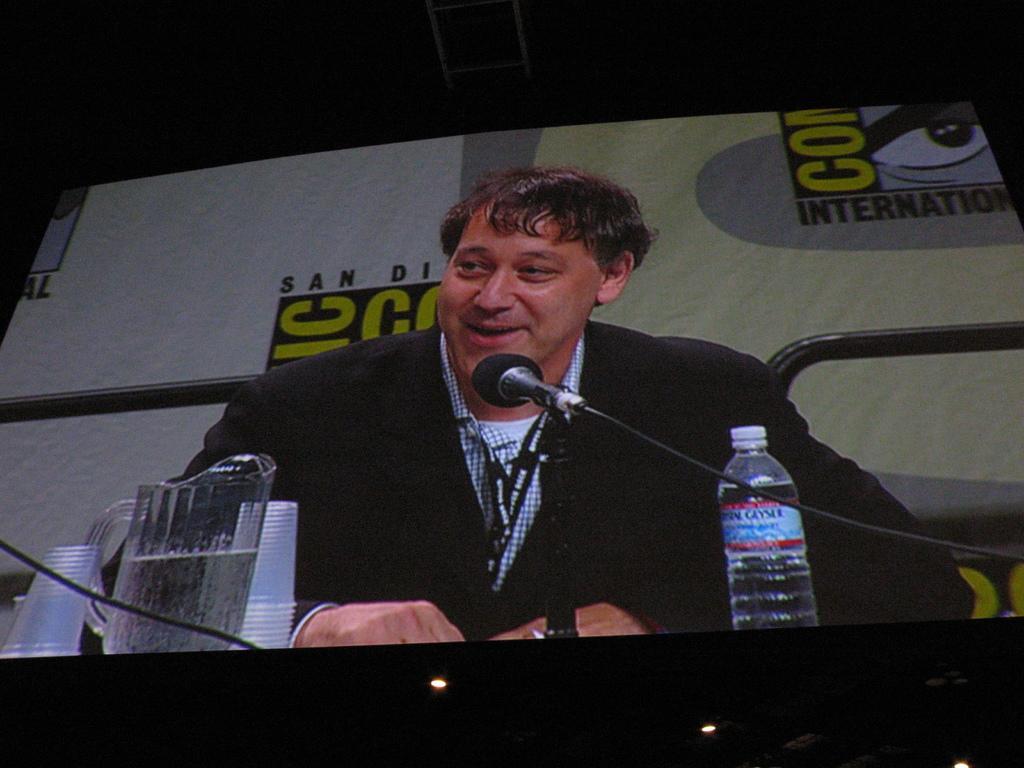Please provide a concise description of this image. In the picture we can see a screen. On the screen we can find a man talking into microphone, near to him there is a desk on the desk we can find a jug, glasses and of water, a man is wearing a blazer with tag. 